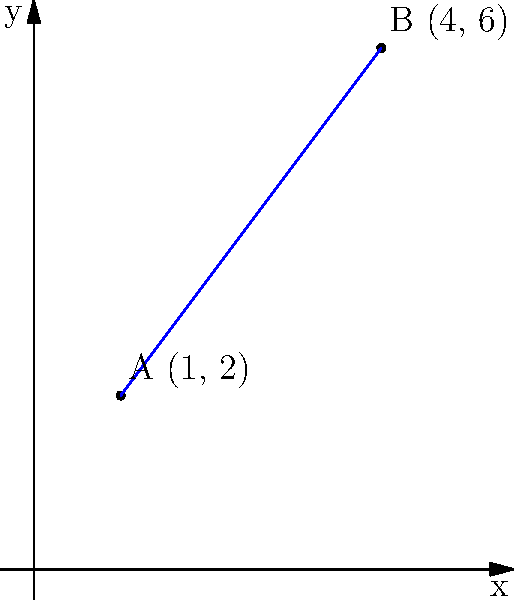On a coordinate plane representing healthy food choices, point A (1, 2) represents a fruit salad, and point B (4, 6) represents a vegetable stir-fry. Calculate the distance between these two nutritious options to determine the variety in a balanced meal plan. To find the distance between two points on a coordinate plane, we can use the distance formula:

$$d = \sqrt{(x_2 - x_1)^2 + (y_2 - y_1)^2}$$

Where $(x_1, y_1)$ is the first point and $(x_2, y_2)$ is the second point.

Step 1: Identify the coordinates
Point A (fruit salad): $(x_1, y_1) = (1, 2)$
Point B (vegetable stir-fry): $(x_2, y_2) = (4, 6)$

Step 2: Plug the values into the distance formula
$$d = \sqrt{(4 - 1)^2 + (6 - 2)^2}$$

Step 3: Simplify the expressions inside the parentheses
$$d = \sqrt{3^2 + 4^2}$$

Step 4: Calculate the squares
$$d = \sqrt{9 + 16}$$

Step 5: Add the values under the square root
$$d = \sqrt{25}$$

Step 6: Simplify the square root
$$d = 5$$

Therefore, the distance between the fruit salad and the vegetable stir-fry on our healthy food choice coordinate plane is 5 units.
Answer: 5 units 